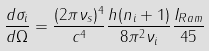<formula> <loc_0><loc_0><loc_500><loc_500>\frac { d \sigma _ { i } } { d \Omega } = \frac { ( 2 \pi \nu _ { s } ) ^ { 4 } } { c ^ { 4 } } \frac { h ( n _ { i } + 1 ) } { 8 \pi ^ { 2 } \nu _ { i } } \frac { I _ { R a m } } { 4 5 }</formula> 